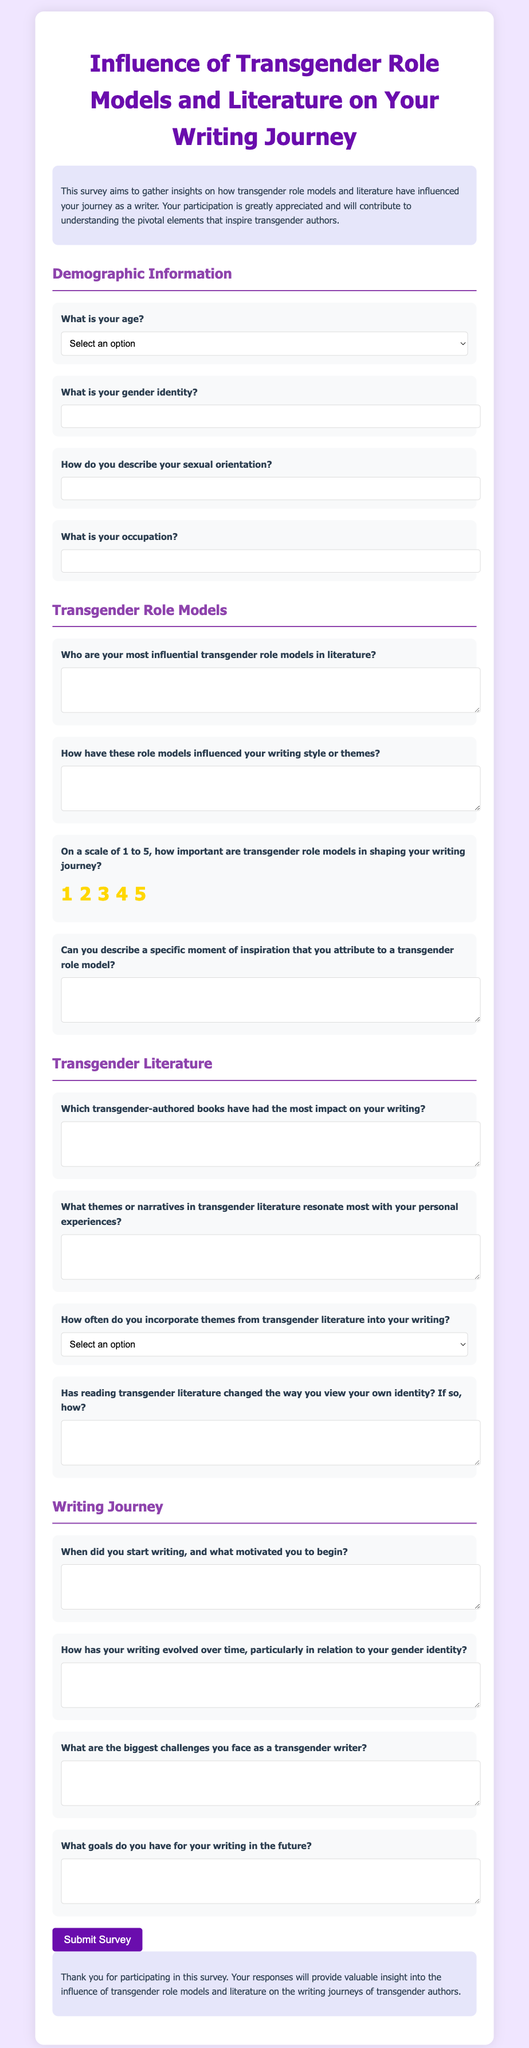What is the title of the survey? The title is explicitly stated at the top of the document.
Answer: Influence of Transgender Role Models and Literature on Your Writing Journey How many demographic questions are included in the survey? The number of demographic questions is inferred from the section titled "Demographic Information."
Answer: Four What is one of the options for the age group in the survey? The age options are listed in the dropdown menu within the age question.
Answer: 18-24 What is the background color of the survey body? The background color is specified in the style section of the document.
Answer: #f0e6ff What is the highest rating option for the importance of transgender role models? The rating options are provided under the rating question about transgender role models.
Answer: 5 What type of writing themes does the survey inquire about? The specific inquiry about themes is reflected in the questions regarding personal experiences in the literature section.
Answer: Transgender themes What is requested in the question about specific moments of inspiration? This question asks for a description based on the influence of role models.
Answer: A specific moment of inspiration How is the survey submitted? The survey submission method is described in the script at the bottom of the document.
Answer: Button click 